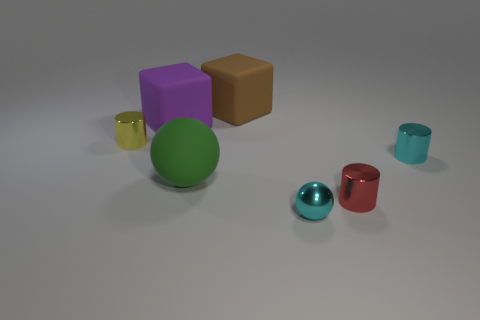Add 2 green spheres. How many objects exist? 9 Subtract all balls. How many objects are left? 5 Add 6 green spheres. How many green spheres are left? 7 Add 3 big blue matte cylinders. How many big blue matte cylinders exist? 3 Subtract 0 purple cylinders. How many objects are left? 7 Subtract all large green cubes. Subtract all metal objects. How many objects are left? 3 